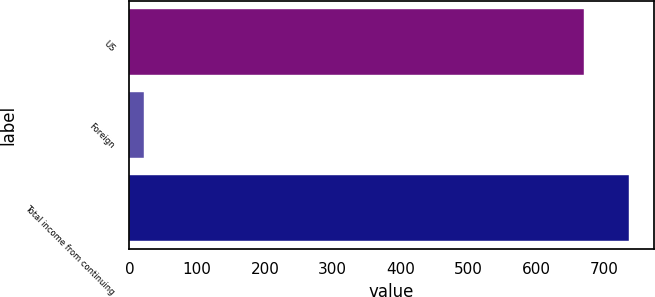Convert chart. <chart><loc_0><loc_0><loc_500><loc_500><bar_chart><fcel>US<fcel>Foreign<fcel>Total income from continuing<nl><fcel>669.9<fcel>21.1<fcel>736.89<nl></chart> 